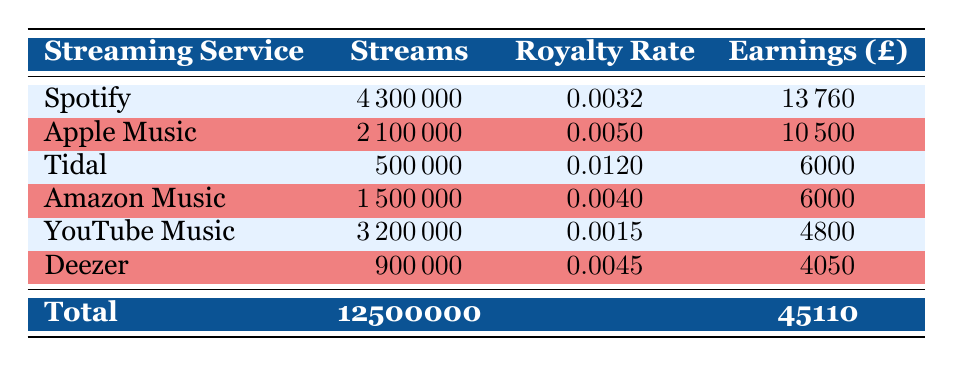What is the total number of streams across all services? To find the total number of streams, add the streams for each streaming service: 4300000 (Spotify) + 2100000 (Apple Music) + 500000 (Tidal) + 1500000 (Amazon Music) + 3200000 (YouTube Music) + 900000 (Deezer) = 12500000.
Answer: 12500000 Which streaming service generated the highest earnings? To determine the service with the highest earnings, compare the earnings of each service: Spotify (£13760), Apple Music (£10500), Tidal (£6000), Amazon Music (£6000), YouTube Music (£4800), and Deezer (£4050). Spotify has the highest earnings of £13760.
Answer: Spotify What is the average royalty rate per stream across all services? To find the average royalty rate, sum the royalty rates and divide by the number of services: (0.0032 + 0.005 + 0.012 + 0.004 + 0.0015 + 0.0045) / 6 = 0.0302 / 6 = 0.005033.
Answer: 0.0050 Is it true that YouTube Music earned more than Amazon Music in royalties? Compare the earnings: YouTube Music earned £4800 while Amazon Music earned £6000. Since £4800 is less than £6000, the statement is false.
Answer: False How much did Charlotte Church earn from Apple Music and Spotify combined? To calculate the combined earnings from these two services, add the earnings: Apple Music £10500 + Spotify £13760 = £24260.
Answer: £24260 What percentage of total earnings came from Tidal? To find the percentage contribution of Tidal's earnings to the total earnings, use the formula: (earnings from Tidal / total earnings) * 100 = (6000 / 45110) * 100 ≈ 13.29%.
Answer: 13.29% Which service had the lowest number of streams? Compare the streams for each service: Spotify (4300000), Apple Music (2100000), Tidal (500000), Amazon Music (1500000), YouTube Music (3200000), and Deezer (900000). Tidal, with 500000 streams, had the lowest.
Answer: Tidal What is the difference in earnings between the highest and lowest earning services? Identify the highest (£13760 from Spotify) and lowest (£4050 from Deezer) earnings. The difference is £13760 - £4050 = £9700.
Answer: £9700 